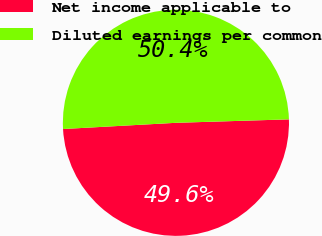Convert chart to OTSL. <chart><loc_0><loc_0><loc_500><loc_500><pie_chart><fcel>Net income applicable to<fcel>Diluted earnings per common<nl><fcel>49.61%<fcel>50.39%<nl></chart> 